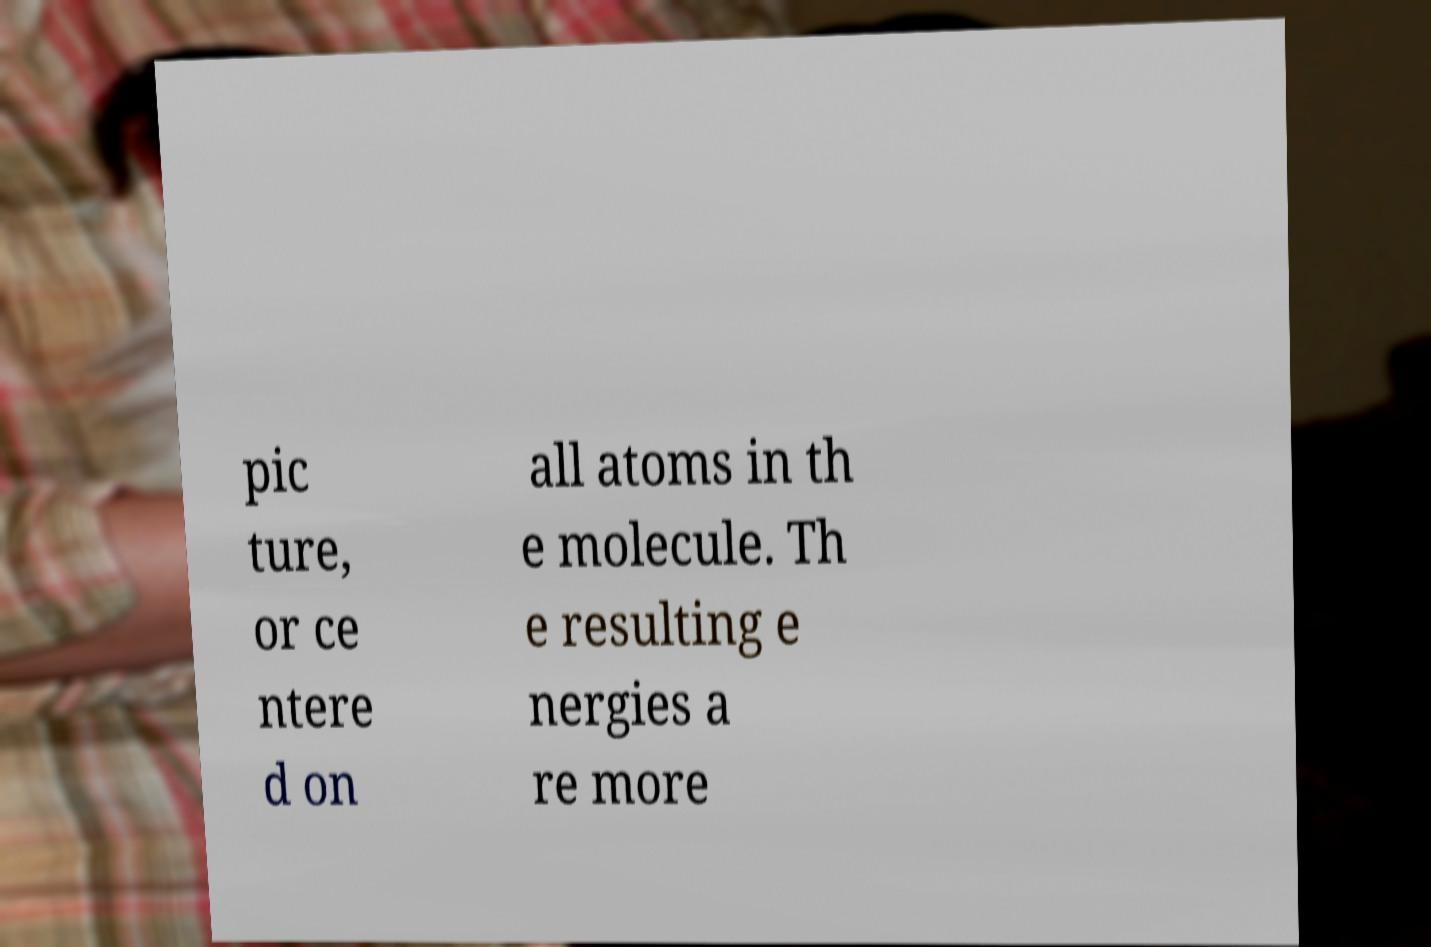Please identify and transcribe the text found in this image. pic ture, or ce ntere d on all atoms in th e molecule. Th e resulting e nergies a re more 